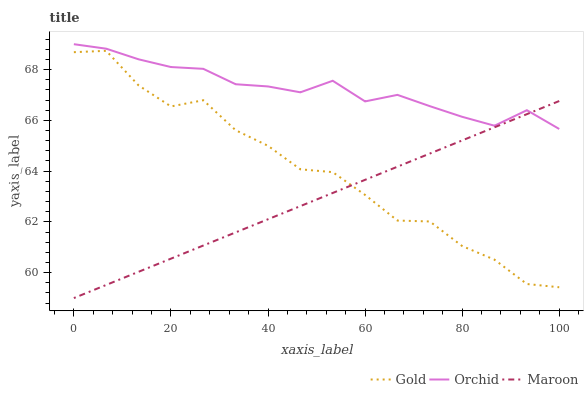Does Maroon have the minimum area under the curve?
Answer yes or no. Yes. Does Orchid have the maximum area under the curve?
Answer yes or no. Yes. Does Gold have the minimum area under the curve?
Answer yes or no. No. Does Gold have the maximum area under the curve?
Answer yes or no. No. Is Maroon the smoothest?
Answer yes or no. Yes. Is Gold the roughest?
Answer yes or no. Yes. Is Orchid the smoothest?
Answer yes or no. No. Is Orchid the roughest?
Answer yes or no. No. Does Maroon have the lowest value?
Answer yes or no. Yes. Does Gold have the lowest value?
Answer yes or no. No. Does Orchid have the highest value?
Answer yes or no. Yes. Does Gold have the highest value?
Answer yes or no. No. Is Gold less than Orchid?
Answer yes or no. Yes. Is Orchid greater than Gold?
Answer yes or no. Yes. Does Orchid intersect Maroon?
Answer yes or no. Yes. Is Orchid less than Maroon?
Answer yes or no. No. Is Orchid greater than Maroon?
Answer yes or no. No. Does Gold intersect Orchid?
Answer yes or no. No. 